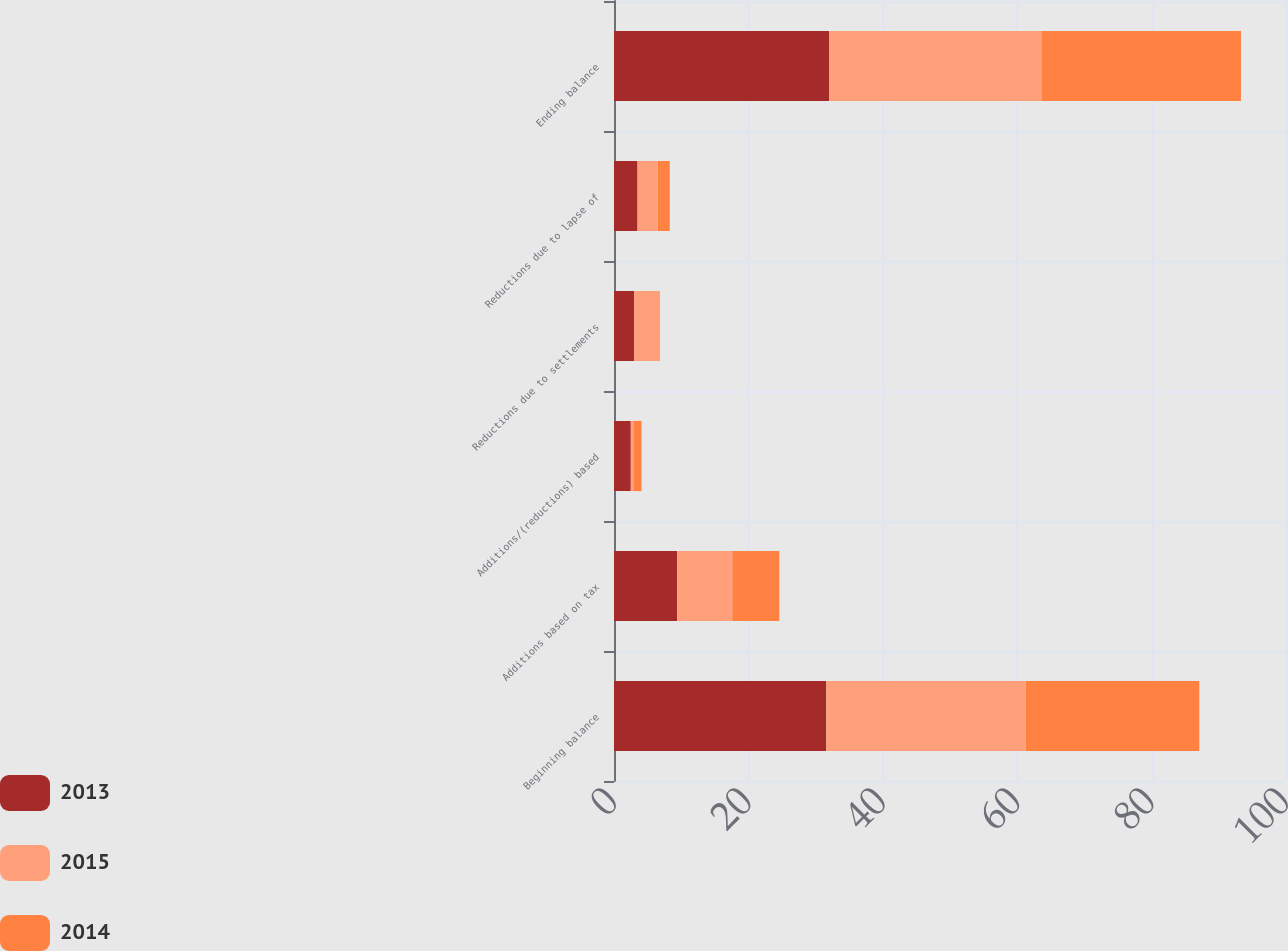Convert chart. <chart><loc_0><loc_0><loc_500><loc_500><stacked_bar_chart><ecel><fcel>Beginning balance<fcel>Additions based on tax<fcel>Additions/(reductions) based<fcel>Reductions due to settlements<fcel>Reductions due to lapse of<fcel>Ending balance<nl><fcel>2013<fcel>31.6<fcel>9.4<fcel>2.5<fcel>3<fcel>3.5<fcel>32<nl><fcel>2015<fcel>29.7<fcel>8.2<fcel>0.4<fcel>3.7<fcel>3<fcel>31.6<nl><fcel>2014<fcel>25.8<fcel>7<fcel>1.2<fcel>0.1<fcel>1.8<fcel>29.7<nl></chart> 